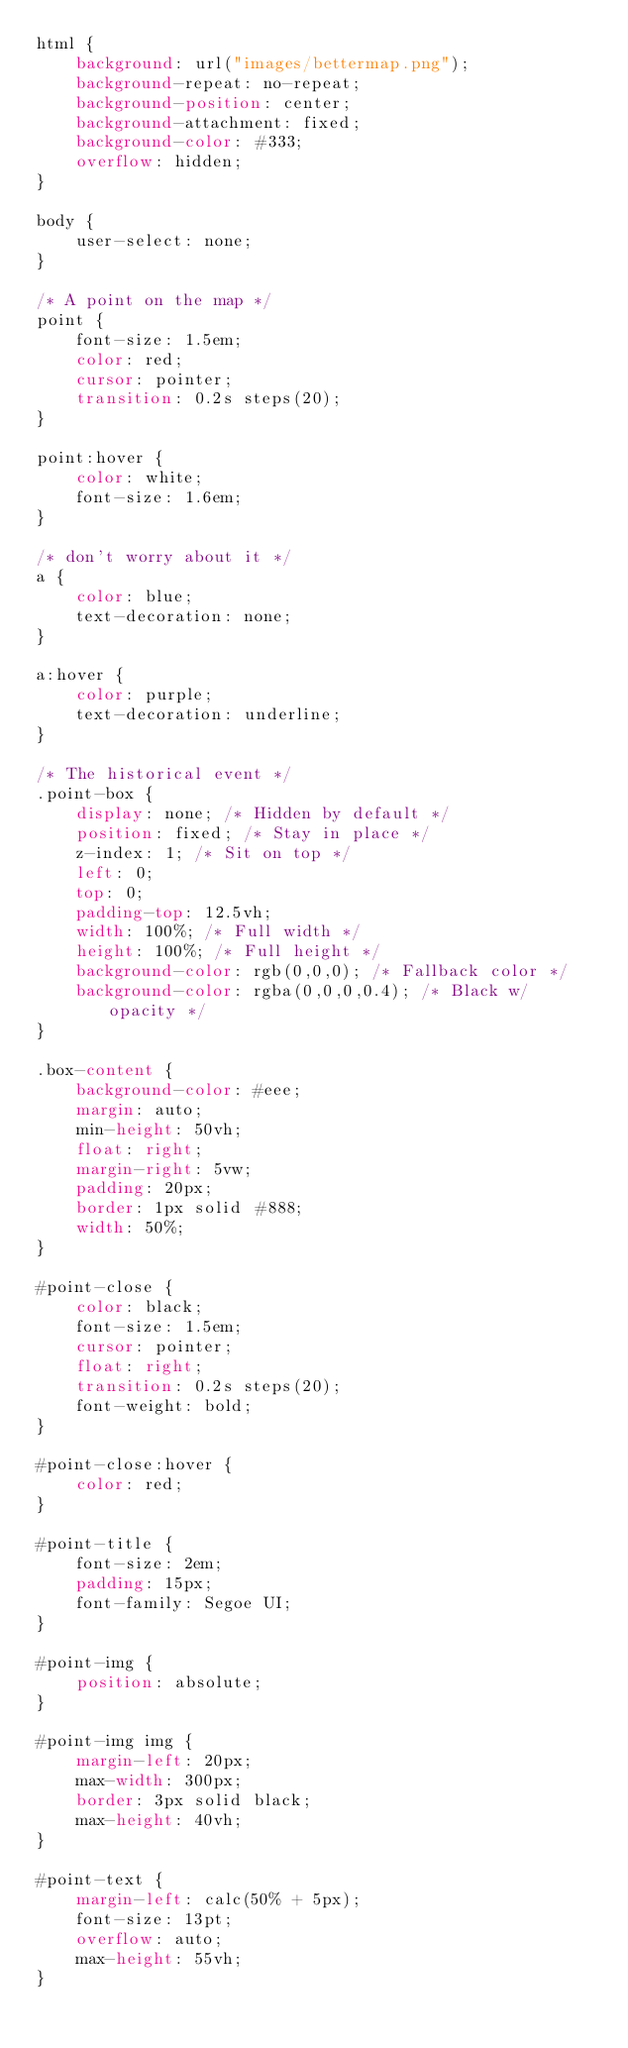<code> <loc_0><loc_0><loc_500><loc_500><_CSS_>html {
    background: url("images/bettermap.png");
    background-repeat: no-repeat;
    background-position: center;
    background-attachment: fixed;
    background-color: #333;
    overflow: hidden;
}

body {
    user-select: none;
}

/* A point on the map */
point {
    font-size: 1.5em;
    color: red;
    cursor: pointer;
    transition: 0.2s steps(20);
}

point:hover {
    color: white;
    font-size: 1.6em;
}

/* don't worry about it */
a {
    color: blue;
    text-decoration: none;
}

a:hover {
    color: purple;
    text-decoration: underline;
}

/* The historical event */
.point-box {
    display: none; /* Hidden by default */
    position: fixed; /* Stay in place */
    z-index: 1; /* Sit on top */
    left: 0;
    top: 0;
    padding-top: 12.5vh;
    width: 100%; /* Full width */
    height: 100%; /* Full height */
    background-color: rgb(0,0,0); /* Fallback color */
    background-color: rgba(0,0,0,0.4); /* Black w/ opacity */
}

.box-content {
    background-color: #eee;
    margin: auto;
    min-height: 50vh;
    float: right;
    margin-right: 5vw;
    padding: 20px;
    border: 1px solid #888;
    width: 50%;
}

#point-close {
    color: black;
    font-size: 1.5em;
    cursor: pointer;
    float: right;
    transition: 0.2s steps(20);
    font-weight: bold;
}

#point-close:hover {
    color: red;
}

#point-title {
    font-size: 2em;
    padding: 15px;
    font-family: Segoe UI;
}

#point-img {
    position: absolute;
}

#point-img img {
    margin-left: 20px;
    max-width: 300px;
    border: 3px solid black;
    max-height: 40vh;
}

#point-text {
    margin-left: calc(50% + 5px);
    font-size: 13pt;
    overflow: auto;
    max-height: 55vh;
}</code> 